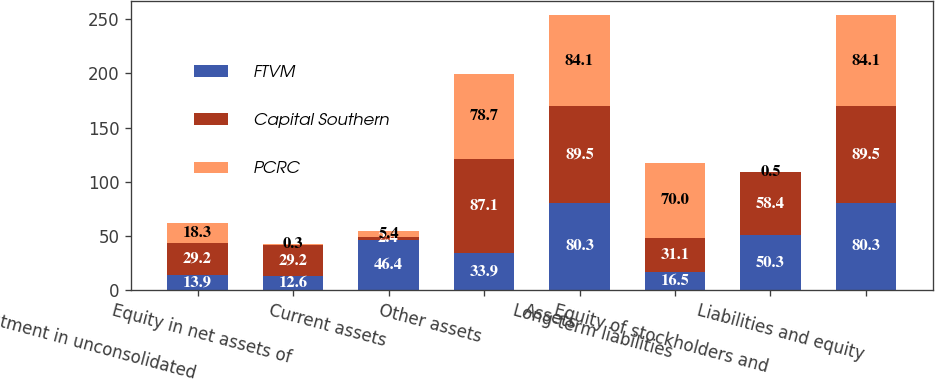<chart> <loc_0><loc_0><loc_500><loc_500><stacked_bar_chart><ecel><fcel>Investment in unconsolidated<fcel>Equity in net assets of<fcel>Current assets<fcel>Other assets<fcel>Assets<fcel>Long-term liabilities<fcel>Equity of stockholders and<fcel>Liabilities and equity<nl><fcel>FTVM<fcel>13.9<fcel>12.6<fcel>46.4<fcel>33.9<fcel>80.3<fcel>16.5<fcel>50.3<fcel>80.3<nl><fcel>Capital Southern<fcel>29.2<fcel>29.2<fcel>2.4<fcel>87.1<fcel>89.5<fcel>31.1<fcel>58.4<fcel>89.5<nl><fcel>PCRC<fcel>18.3<fcel>0.3<fcel>5.4<fcel>78.7<fcel>84.1<fcel>70<fcel>0.5<fcel>84.1<nl></chart> 